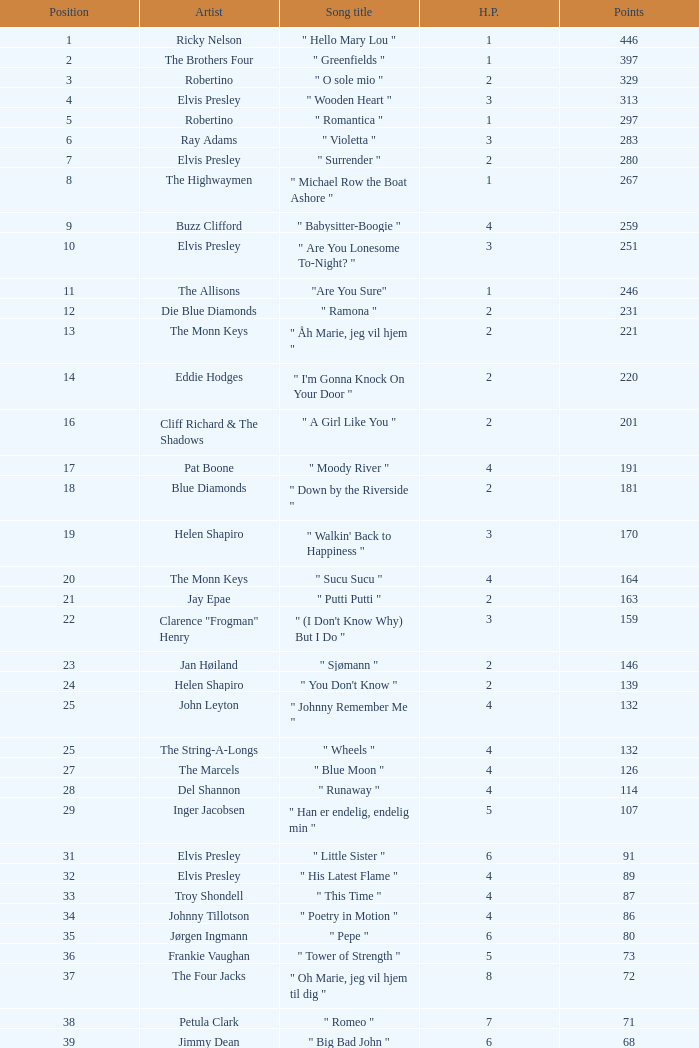What is the title of the song that received 259 points? " Babysitter-Boogie ". 